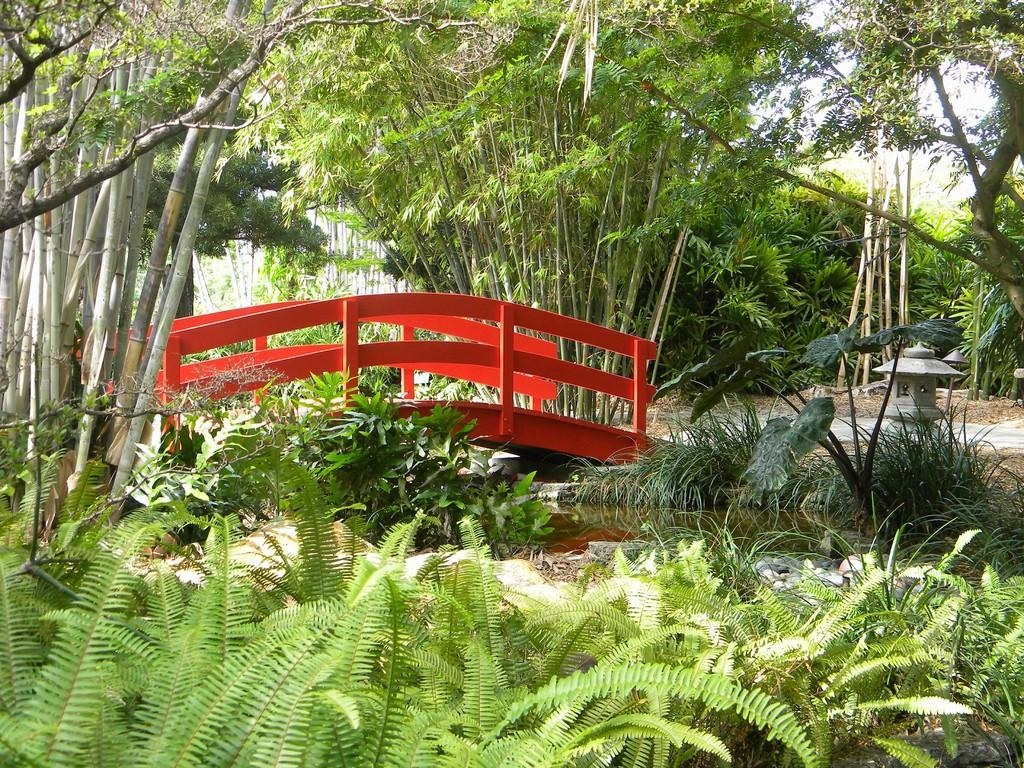What type of structure can be seen in the image? There is a walkway bridge in the image. What type of vegetation is present in the image? Shrubs, plants, trees, and bushes are visible in the image. What natural element is visible in the image? There is water in the image. What part of the natural environment is visible in the image? The sky is visible in the image. What scientific discovery is being made in the image? There is no indication of a scientific discovery being made in the image. What type of crow can be seen in the image? There are no crows present in the image. 